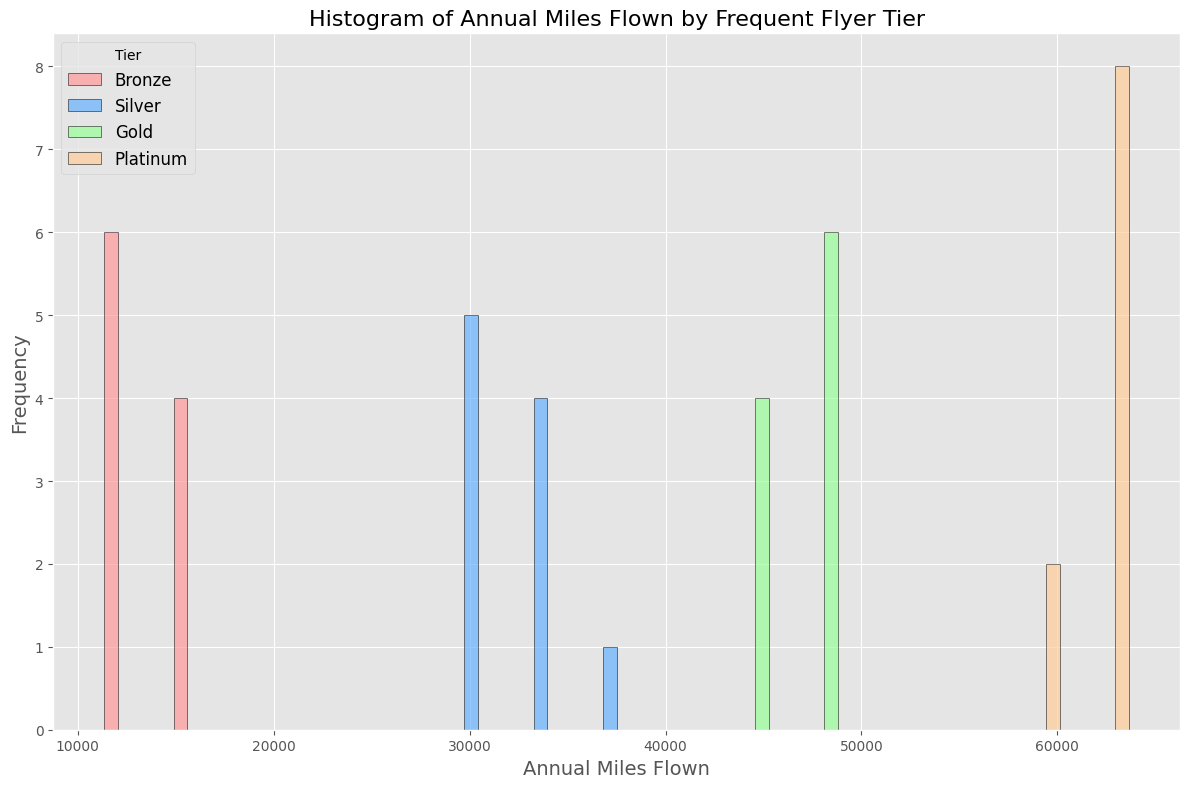Which tier has the highest frequency of Annual Miles Flown around 15,000? By looking at the histogram, we need to observe which bar around the 15,000 miles marker is the tallest. Since the Bronze tier mainly occupies this range, we conclude it has the highest frequency.
Answer: Bronze Which tier shows the widest range of Annual Miles Flown values? To determine the widest range, we assess the horizontal span of the bars for each tier in the histogram. The Platinum tier spans from 59,000 to 64,000 miles, showcasing the widest range.
Answer: Platinum How do the average annual miles flown for the Bronze tier compare to the average for the Silver tier? First, calculate the average annual miles flown for both tiers by their respective data points provided. Bronze average: (15000 + 12000 + 17000 + 11000 + 14000 + 13000 + 16000 + 18000 + 12500 + 13500) / 10 = 14200. Silver average: (30000 + 35000 + 32000 + 31000 + 29000 + 33000 + 34000 + 36000 + 31500 + 32500) / 10 = 32400. Comparatively, the Silver tier has a higher average annual miles flown than the Bronze tier.
Answer: Silver has a higher average In terms of visual height on the histogram, which tier has the least frequency? The tier with the shortest bars across the x-axis indicates the least frequency. The Gold and Platinum tiers have the smallest bars, indicating fewer flights per year in shorter ranges.
Answer: Gold and Platinum What is the median value of Annual Miles Flown for the Gold tier? To find the median, list the values for the Gold tier in ascending order: 44000, 45000, 45500, 46000, 46500, 47000, 47500, 48000, 48500, 49000. The median is the middle value (5th and 6th), so (46500 + 47000)/2 = 46750.
Answer: 46750 Which tier has the most concentrated frequency of Annual Miles Flown around 30,000 miles? By inspecting the histogram, we need to see which tier's bars are concentrated around the 30,000 miles mark. The Silver tier predominantly has this characteristic.
Answer: Silver Compare the range of Annual Miles Flown in the Bronze tier to that of the Platinum tier. For the Bronze tier, the range is calculated by subtracting the smallest value from the largest value: 18000 - 11000 = 7000. For the Platinum tier, it's 64000 - 59000 = 5000. Therefore, Bronze has a wider range compared to Platinum.
Answer: Bronze has a wider range What is the color of the bars representing the Gold tier? By examining the histogram, one can see that bars representing the Gold tier are displayed in a distinct color, which is visually identifiable as green.
Answer: Green 